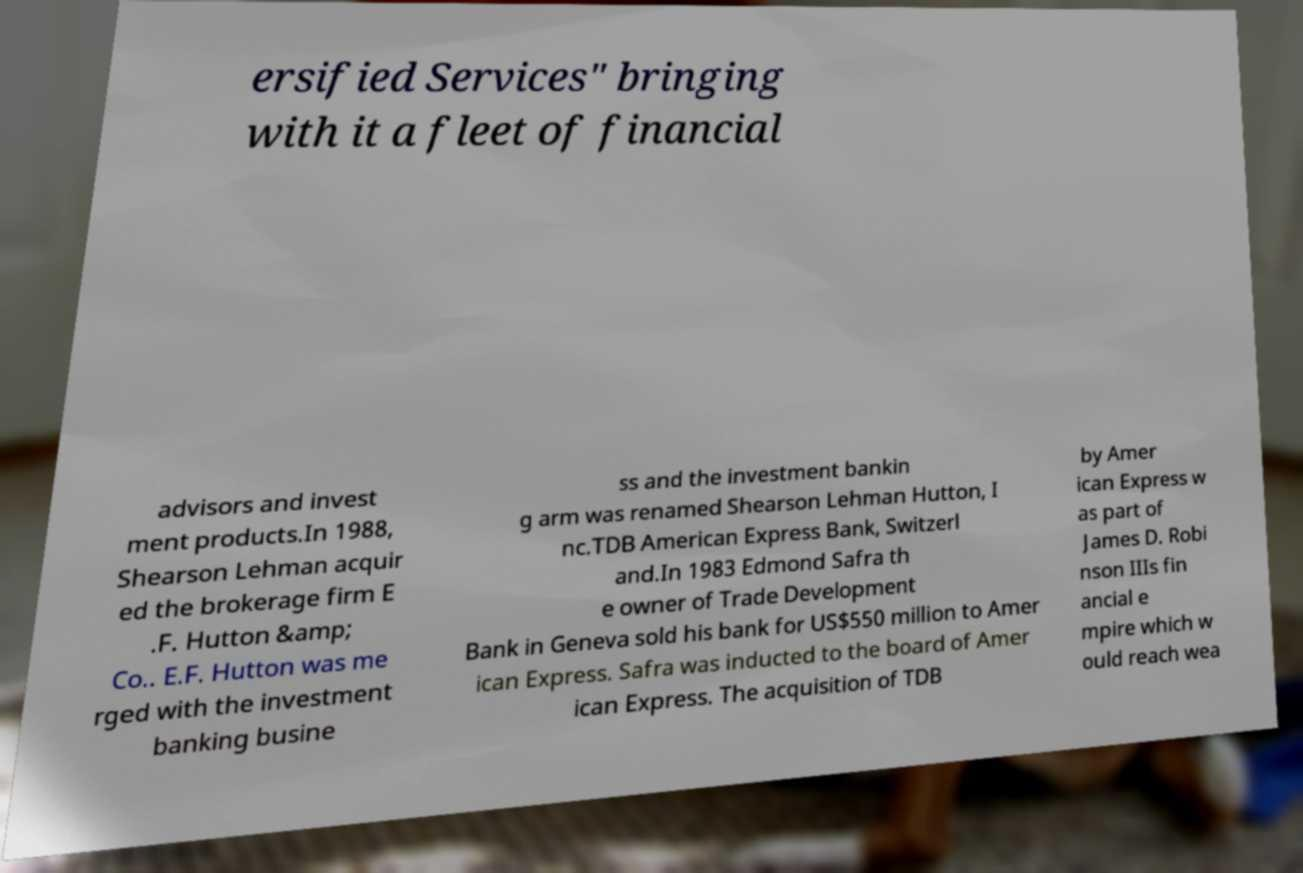Could you assist in decoding the text presented in this image and type it out clearly? ersified Services" bringing with it a fleet of financial advisors and invest ment products.In 1988, Shearson Lehman acquir ed the brokerage firm E .F. Hutton &amp; Co.. E.F. Hutton was me rged with the investment banking busine ss and the investment bankin g arm was renamed Shearson Lehman Hutton, I nc.TDB American Express Bank, Switzerl and.In 1983 Edmond Safra th e owner of Trade Development Bank in Geneva sold his bank for US$550 million to Amer ican Express. Safra was inducted to the board of Amer ican Express. The acquisition of TDB by Amer ican Express w as part of James D. Robi nson IIIs fin ancial e mpire which w ould reach wea 